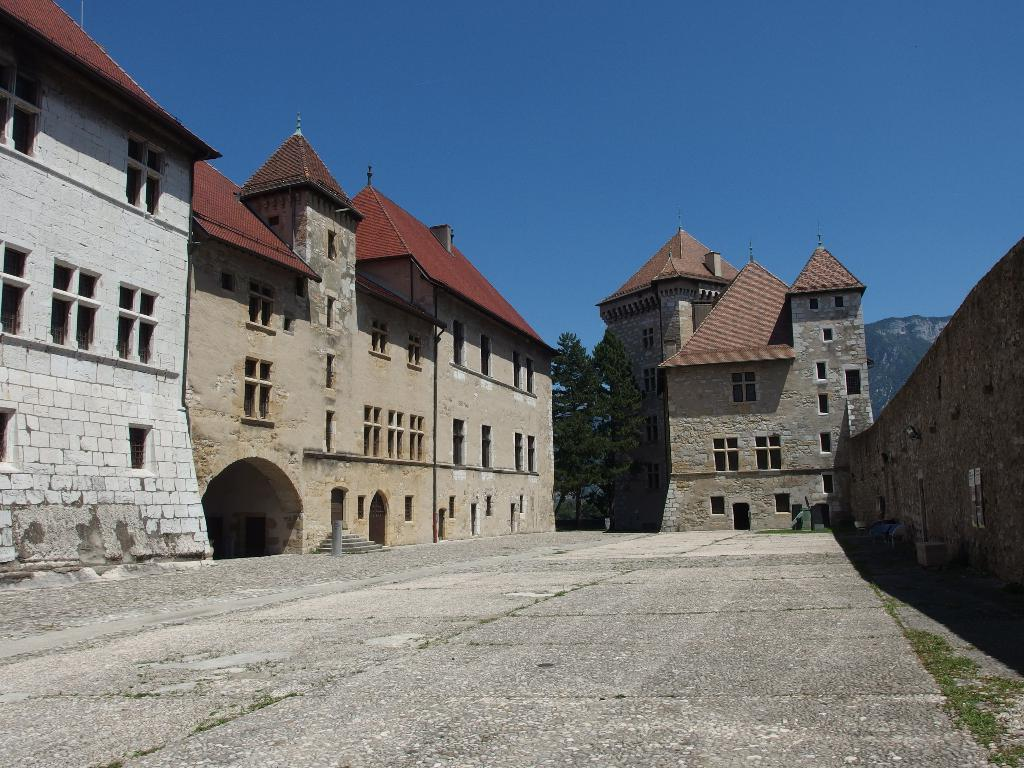What is located at the bottom of the image? There is a road at the bottom of the image. What can be seen in the background of the image? There are buildings and trees in the background of the image. What is visible at the top of the image? The sky is visible at the top of the image. What type of education can be seen taking place on the sidewalk in the image? There is no sidewalk or education present in the image; it features a road, buildings, trees, and the sky. 